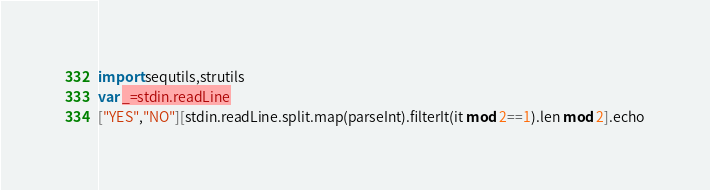Convert code to text. <code><loc_0><loc_0><loc_500><loc_500><_Nim_>import sequtils,strutils
var _=stdin.readLine
["YES","NO"][stdin.readLine.split.map(parseInt).filterIt(it mod 2==1).len mod 2].echo</code> 